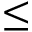<formula> <loc_0><loc_0><loc_500><loc_500>\leq</formula> 